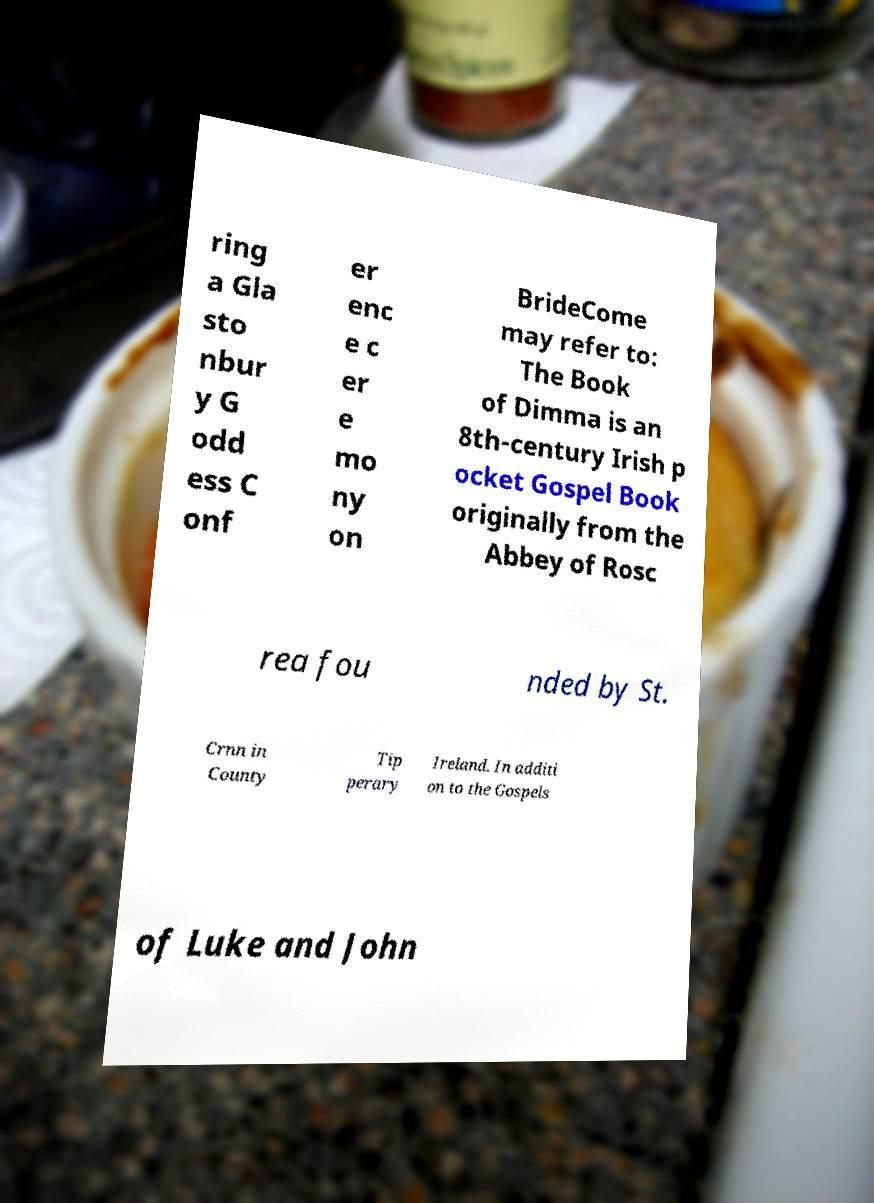Could you extract and type out the text from this image? ring a Gla sto nbur y G odd ess C onf er enc e c er e mo ny on BrideCome may refer to: The Book of Dimma is an 8th-century Irish p ocket Gospel Book originally from the Abbey of Rosc rea fou nded by St. Crnn in County Tip perary Ireland. In additi on to the Gospels of Luke and John 